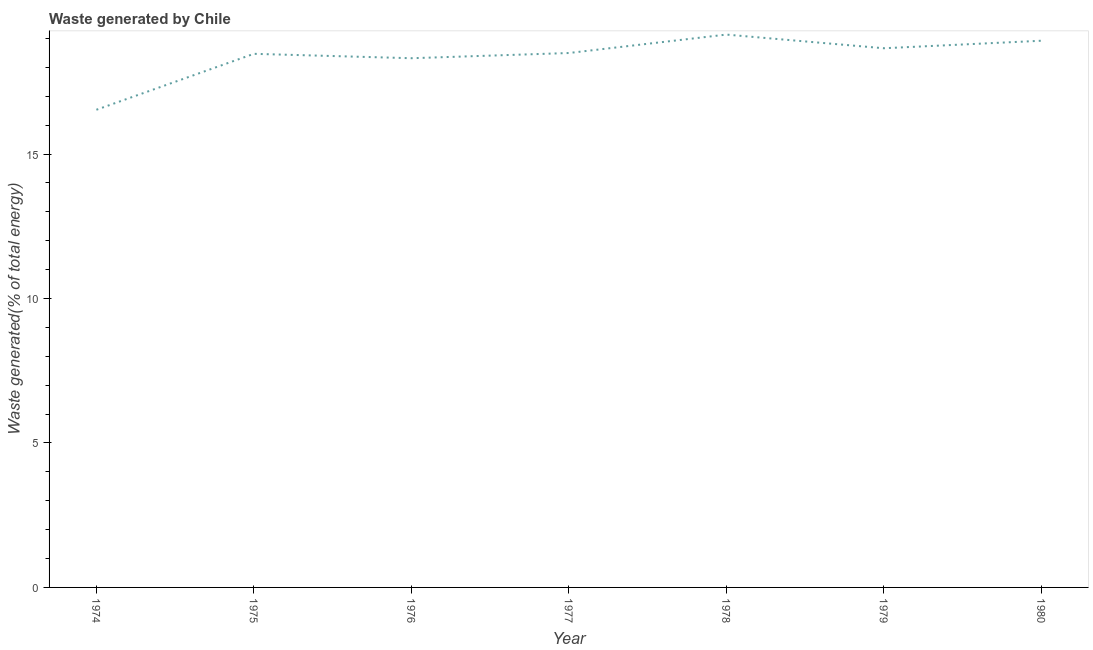What is the amount of waste generated in 1974?
Offer a terse response. 16.53. Across all years, what is the maximum amount of waste generated?
Offer a very short reply. 19.13. Across all years, what is the minimum amount of waste generated?
Your response must be concise. 16.53. In which year was the amount of waste generated maximum?
Offer a terse response. 1978. In which year was the amount of waste generated minimum?
Your answer should be compact. 1974. What is the sum of the amount of waste generated?
Offer a very short reply. 128.52. What is the difference between the amount of waste generated in 1975 and 1976?
Ensure brevity in your answer.  0.15. What is the average amount of waste generated per year?
Your answer should be very brief. 18.36. What is the median amount of waste generated?
Keep it short and to the point. 18.5. What is the ratio of the amount of waste generated in 1979 to that in 1980?
Provide a succinct answer. 0.99. Is the amount of waste generated in 1975 less than that in 1980?
Offer a terse response. Yes. What is the difference between the highest and the second highest amount of waste generated?
Your answer should be very brief. 0.21. Is the sum of the amount of waste generated in 1974 and 1976 greater than the maximum amount of waste generated across all years?
Make the answer very short. Yes. What is the difference between the highest and the lowest amount of waste generated?
Give a very brief answer. 2.6. How many years are there in the graph?
Your answer should be compact. 7. What is the difference between two consecutive major ticks on the Y-axis?
Ensure brevity in your answer.  5. Are the values on the major ticks of Y-axis written in scientific E-notation?
Your answer should be compact. No. Does the graph contain grids?
Keep it short and to the point. No. What is the title of the graph?
Offer a terse response. Waste generated by Chile. What is the label or title of the X-axis?
Offer a terse response. Year. What is the label or title of the Y-axis?
Give a very brief answer. Waste generated(% of total energy). What is the Waste generated(% of total energy) of 1974?
Make the answer very short. 16.53. What is the Waste generated(% of total energy) of 1975?
Offer a terse response. 18.47. What is the Waste generated(% of total energy) in 1976?
Provide a short and direct response. 18.32. What is the Waste generated(% of total energy) in 1977?
Provide a succinct answer. 18.5. What is the Waste generated(% of total energy) in 1978?
Offer a terse response. 19.13. What is the Waste generated(% of total energy) in 1979?
Provide a succinct answer. 18.66. What is the Waste generated(% of total energy) of 1980?
Provide a succinct answer. 18.92. What is the difference between the Waste generated(% of total energy) in 1974 and 1975?
Give a very brief answer. -1.94. What is the difference between the Waste generated(% of total energy) in 1974 and 1976?
Your answer should be compact. -1.78. What is the difference between the Waste generated(% of total energy) in 1974 and 1977?
Provide a short and direct response. -1.96. What is the difference between the Waste generated(% of total energy) in 1974 and 1978?
Ensure brevity in your answer.  -2.6. What is the difference between the Waste generated(% of total energy) in 1974 and 1979?
Offer a terse response. -2.13. What is the difference between the Waste generated(% of total energy) in 1974 and 1980?
Make the answer very short. -2.39. What is the difference between the Waste generated(% of total energy) in 1975 and 1976?
Your answer should be very brief. 0.15. What is the difference between the Waste generated(% of total energy) in 1975 and 1977?
Your answer should be compact. -0.03. What is the difference between the Waste generated(% of total energy) in 1975 and 1978?
Provide a short and direct response. -0.67. What is the difference between the Waste generated(% of total energy) in 1975 and 1979?
Offer a terse response. -0.19. What is the difference between the Waste generated(% of total energy) in 1975 and 1980?
Your answer should be very brief. -0.45. What is the difference between the Waste generated(% of total energy) in 1976 and 1977?
Provide a short and direct response. -0.18. What is the difference between the Waste generated(% of total energy) in 1976 and 1978?
Your response must be concise. -0.82. What is the difference between the Waste generated(% of total energy) in 1976 and 1979?
Give a very brief answer. -0.35. What is the difference between the Waste generated(% of total energy) in 1976 and 1980?
Your response must be concise. -0.61. What is the difference between the Waste generated(% of total energy) in 1977 and 1978?
Provide a short and direct response. -0.64. What is the difference between the Waste generated(% of total energy) in 1977 and 1979?
Ensure brevity in your answer.  -0.16. What is the difference between the Waste generated(% of total energy) in 1977 and 1980?
Make the answer very short. -0.42. What is the difference between the Waste generated(% of total energy) in 1978 and 1979?
Give a very brief answer. 0.47. What is the difference between the Waste generated(% of total energy) in 1978 and 1980?
Your response must be concise. 0.21. What is the difference between the Waste generated(% of total energy) in 1979 and 1980?
Offer a terse response. -0.26. What is the ratio of the Waste generated(% of total energy) in 1974 to that in 1975?
Keep it short and to the point. 0.9. What is the ratio of the Waste generated(% of total energy) in 1974 to that in 1976?
Make the answer very short. 0.9. What is the ratio of the Waste generated(% of total energy) in 1974 to that in 1977?
Offer a very short reply. 0.89. What is the ratio of the Waste generated(% of total energy) in 1974 to that in 1978?
Provide a succinct answer. 0.86. What is the ratio of the Waste generated(% of total energy) in 1974 to that in 1979?
Give a very brief answer. 0.89. What is the ratio of the Waste generated(% of total energy) in 1974 to that in 1980?
Offer a very short reply. 0.87. What is the ratio of the Waste generated(% of total energy) in 1975 to that in 1976?
Offer a terse response. 1.01. What is the ratio of the Waste generated(% of total energy) in 1975 to that in 1977?
Your answer should be compact. 1. What is the ratio of the Waste generated(% of total energy) in 1975 to that in 1979?
Your response must be concise. 0.99. What is the ratio of the Waste generated(% of total energy) in 1975 to that in 1980?
Ensure brevity in your answer.  0.98. What is the ratio of the Waste generated(% of total energy) in 1976 to that in 1977?
Your answer should be very brief. 0.99. What is the ratio of the Waste generated(% of total energy) in 1976 to that in 1979?
Your answer should be very brief. 0.98. What is the ratio of the Waste generated(% of total energy) in 1977 to that in 1979?
Your answer should be very brief. 0.99. 